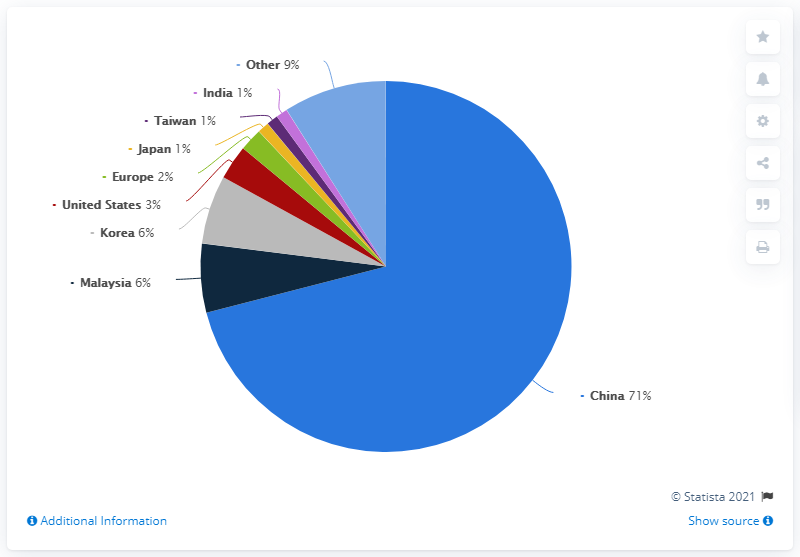Identify some key points in this picture. Eight countries were considered in the graph. The distribution of the sum of India and China is approximately 72.. 